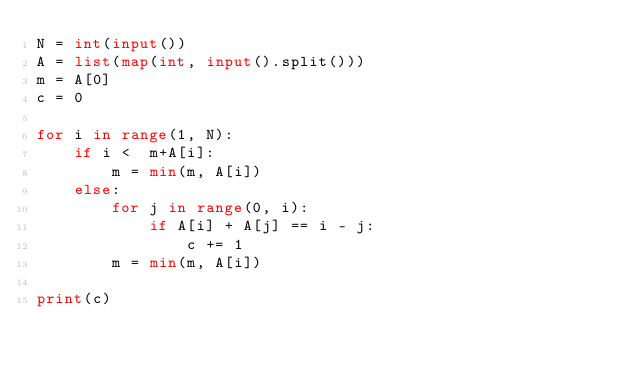<code> <loc_0><loc_0><loc_500><loc_500><_Python_>N = int(input())
A = list(map(int, input().split()))
m = A[0]
c = 0

for i in range(1, N):
    if i <  m+A[i]:
        m = min(m, A[i])
    else:
        for j in range(0, i):
            if A[i] + A[j] == i - j:
                c += 1
        m = min(m, A[i])

print(c)</code> 